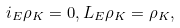<formula> <loc_0><loc_0><loc_500><loc_500>i _ { E } \rho _ { K } = 0 , L _ { E } \rho _ { K } = \rho _ { K } ,</formula> 